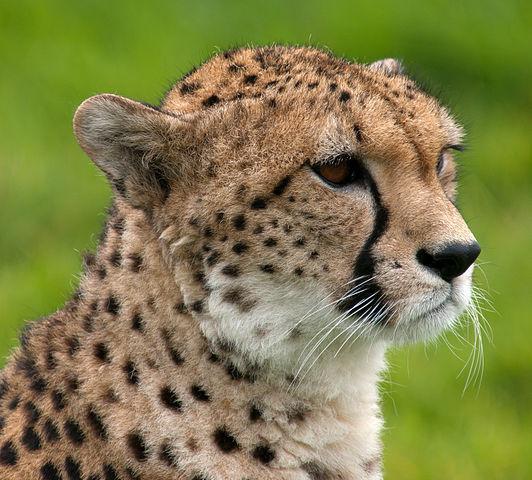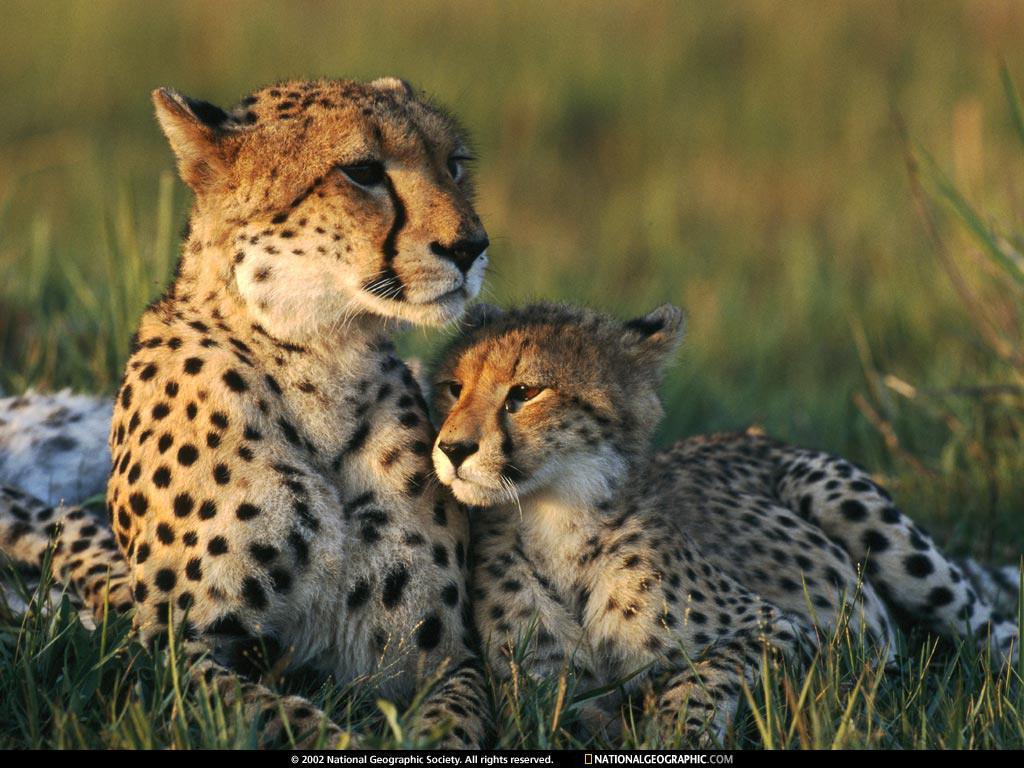The first image is the image on the left, the second image is the image on the right. For the images displayed, is the sentence "One cheetah's front paws are off the ground." factually correct? Answer yes or no. No. The first image is the image on the left, the second image is the image on the right. Analyze the images presented: Is the assertion "One image contains one cheetah, with its neck turned to gaze rightward, and the other image shows one cheetah in profile in a rightward bounding pose, with at least its front paws off the ground." valid? Answer yes or no. No. 